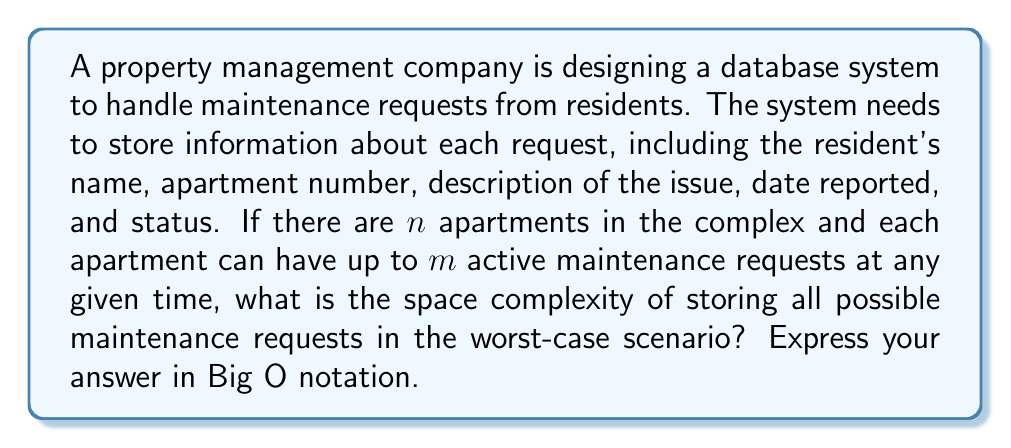Solve this math problem. To analyze the space complexity, let's break down the components of each maintenance request:

1. Resident's name: Assume a fixed-length string of $c_1$ characters
2. Apartment number: Can be represented by an integer, taking $c_2$ bytes
3. Description of the issue: Assume a maximum length of $c_3$ characters
4. Date reported: Can be stored as a timestamp, taking $c_4$ bytes
5. Status: Can be represented by an enum or integer, taking $c_5$ bytes

The total space for one maintenance request is thus $S = c_1 + c_2 + c_3 + c_4 + c_5$ bytes.

In the worst-case scenario:
- There are $n$ apartments
- Each apartment has $m$ active maintenance requests

Therefore, the total number of maintenance requests is $n \times m$.

The total space required to store all possible maintenance requests is:

$$ \text{Total Space} = (n \times m) \times S $$

Since $S$ is a constant (sum of fixed-size components), we can simplify this to:

$$ \text{Total Space} = O(n \times m) $$

This represents the worst-case space complexity of the database system for storing maintenance requests.
Answer: $O(n \times m)$, where $n$ is the number of apartments and $m$ is the maximum number of active maintenance requests per apartment. 